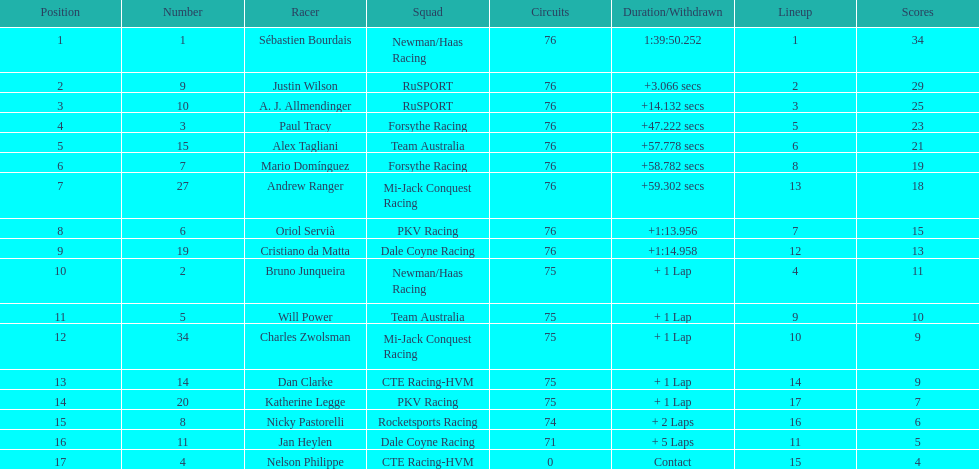What was the total points that canada earned together? 62. 